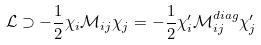Convert formula to latex. <formula><loc_0><loc_0><loc_500><loc_500>\mathcal { L } \supset - \frac { 1 } { 2 } \chi _ { i } \mathcal { M } _ { i j } \chi _ { j } = - \frac { 1 } { 2 } \chi _ { i } ^ { \prime } \mathcal { M } ^ { d i a g } _ { i j } \chi _ { j } ^ { \prime }</formula> 